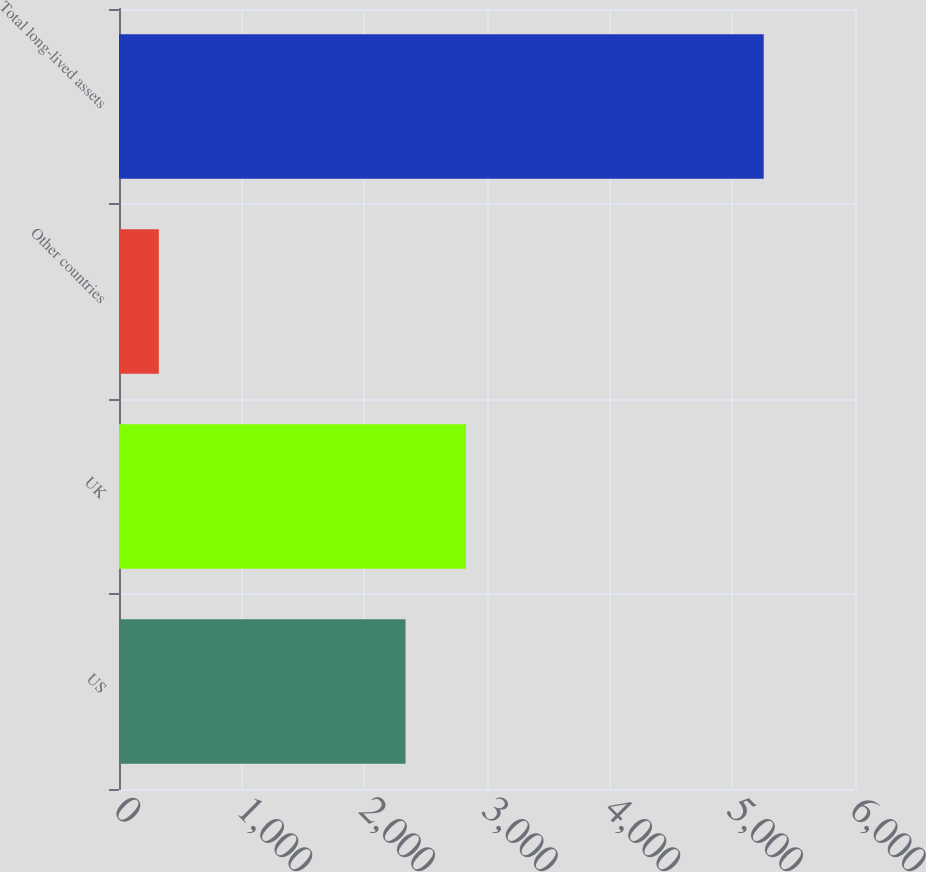<chart> <loc_0><loc_0><loc_500><loc_500><bar_chart><fcel>US<fcel>UK<fcel>Other countries<fcel>Total long-lived assets<nl><fcel>2335.8<fcel>2828.93<fcel>324.5<fcel>5255.8<nl></chart> 